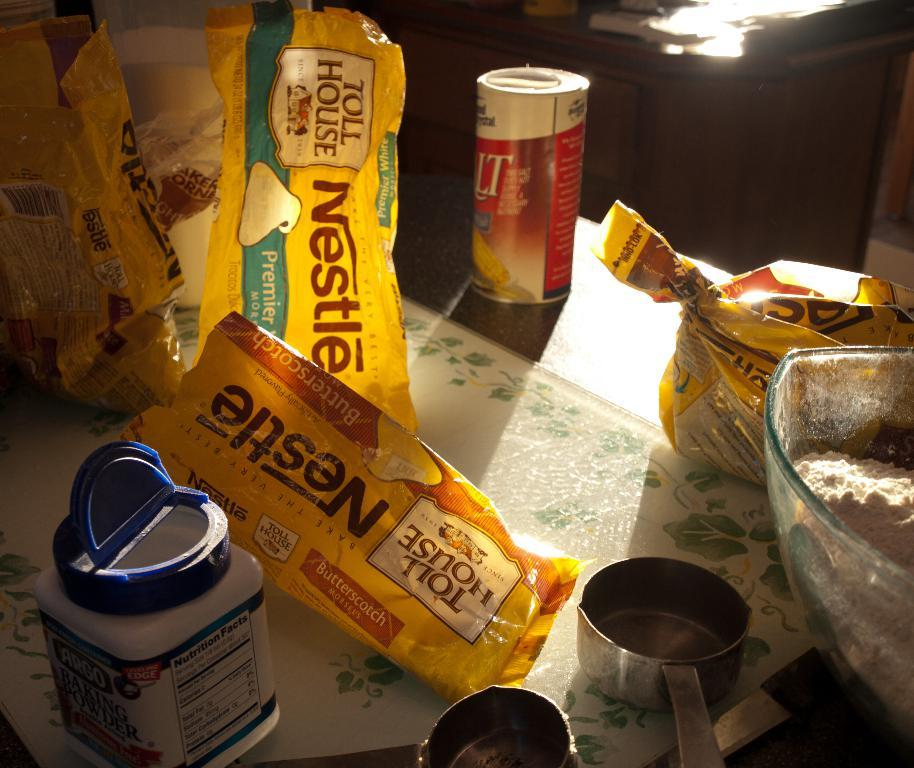<image>
Relay a brief, clear account of the picture shown. Several bags of Nestle chocolate chips on a table. 